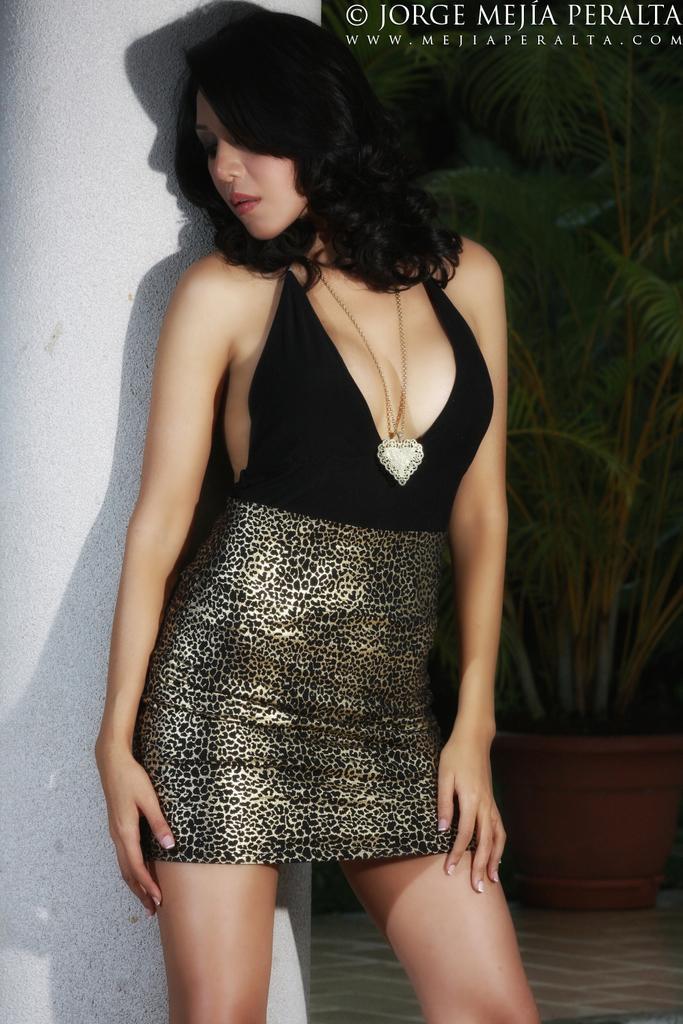Can you describe this image briefly? In this picture there is a man who is wearing black dress. She is standing near to the pillar. In the background we can see plants and power. In the top right corner there is a watermark. 